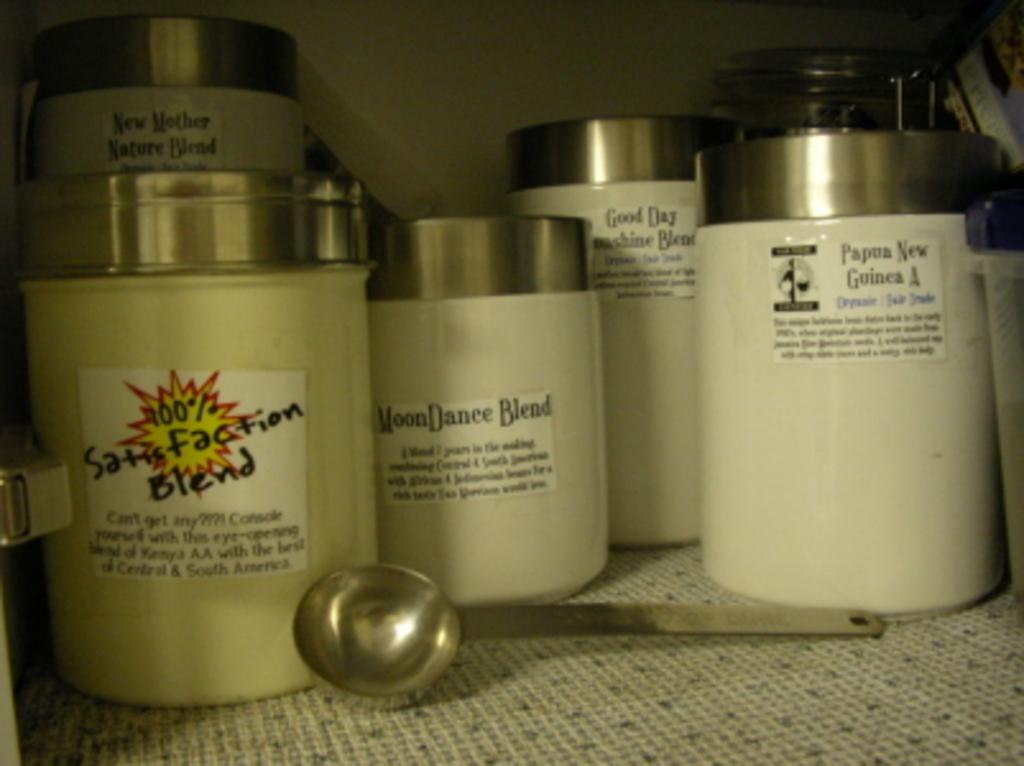<image>
Provide a brief description of the given image. A white bottle that says Moon Dance Blend on it. 